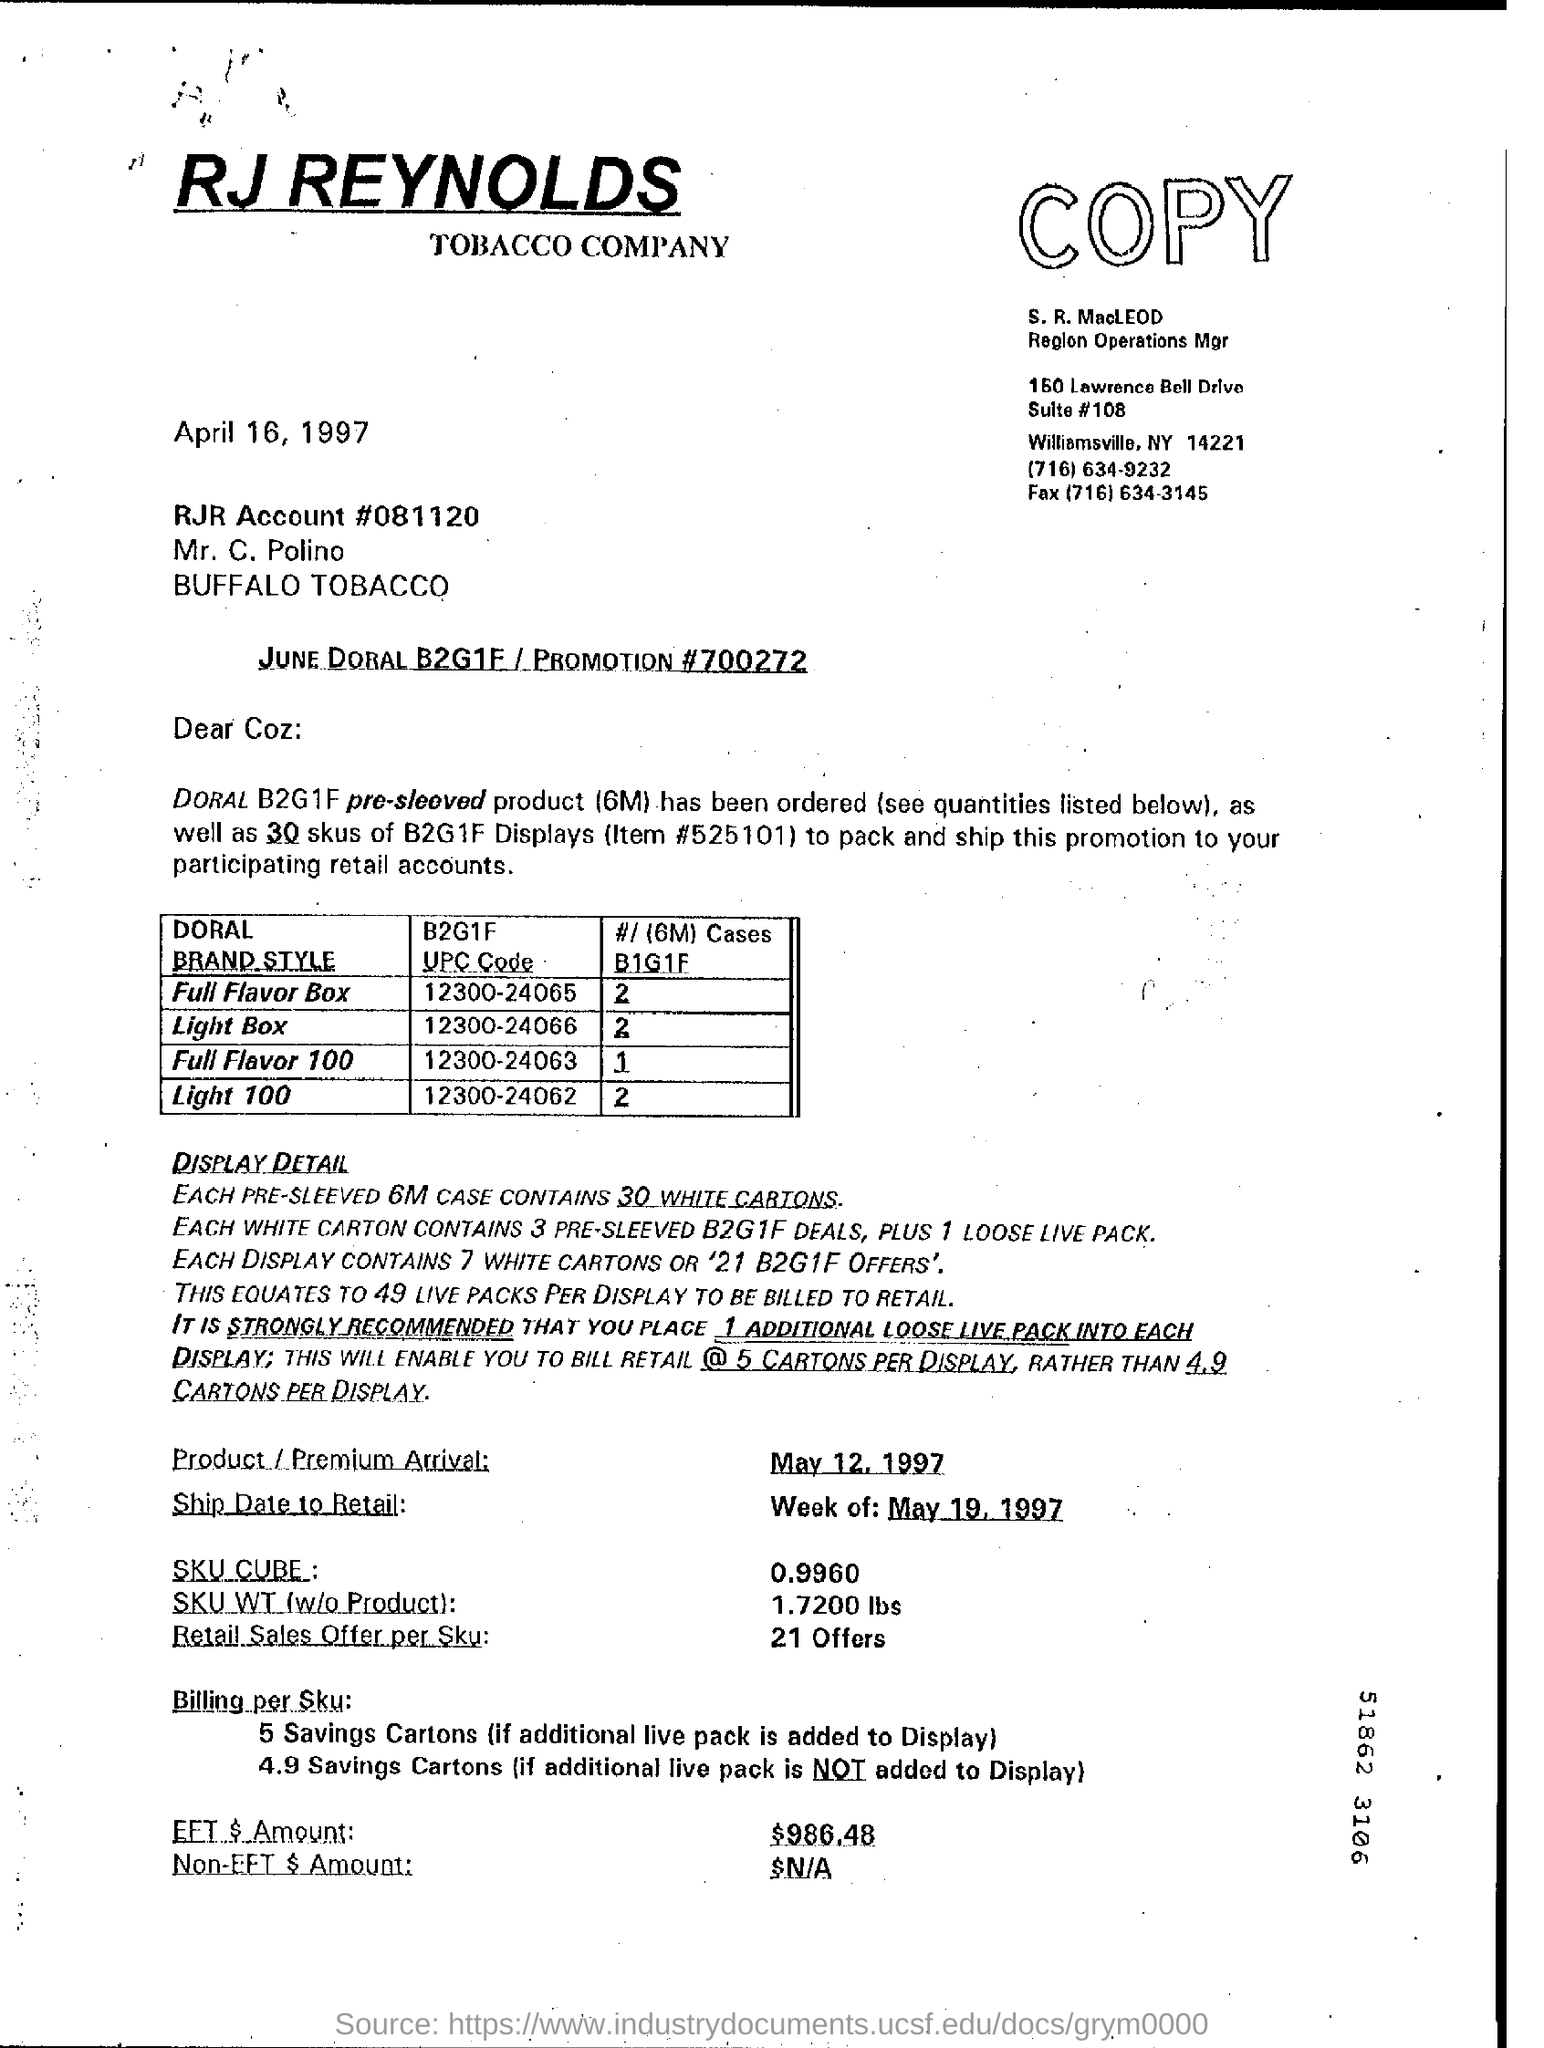How many white cartons are contained in each 6M case?
Keep it short and to the point. 30. When is the product arrival date?
Offer a very short reply. May 12 1997. What is the B2G1F UPC code for "Full Flavour Box"?
Provide a short and direct response. 12300-24065. What is the Fax number of Region Operations Mgr?
Make the answer very short. (716) 634-3145. 